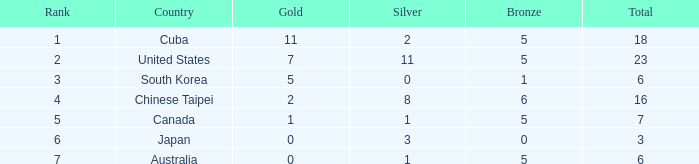What was the sum of the ranks for Japan who had less than 5 bronze medals and more than 3 silvers? None. Help me parse the entirety of this table. {'header': ['Rank', 'Country', 'Gold', 'Silver', 'Bronze', 'Total'], 'rows': [['1', 'Cuba', '11', '2', '5', '18'], ['2', 'United States', '7', '11', '5', '23'], ['3', 'South Korea', '5', '0', '1', '6'], ['4', 'Chinese Taipei', '2', '8', '6', '16'], ['5', 'Canada', '1', '1', '5', '7'], ['6', 'Japan', '0', '3', '0', '3'], ['7', 'Australia', '0', '1', '5', '6']]} 